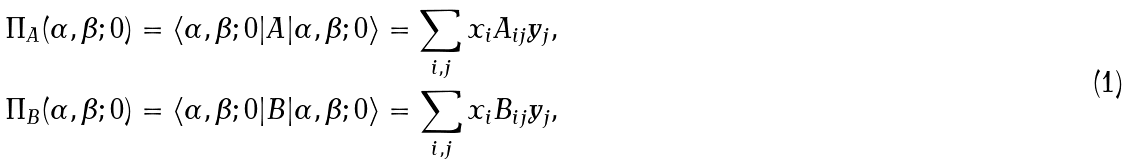Convert formula to latex. <formula><loc_0><loc_0><loc_500><loc_500>& \Pi _ { A } ( \alpha , \beta ; 0 ) = \left < \alpha , \beta ; 0 | A | \alpha , \beta ; 0 \right > = \sum _ { i , j } x _ { i } A _ { i j } y _ { j } , \\ & \Pi _ { B } ( \alpha , \beta ; 0 ) = \left < \alpha , \beta ; 0 | B | \alpha , \beta ; 0 \right > = \sum _ { i , j } x _ { i } B _ { i j } y _ { j } ,</formula> 